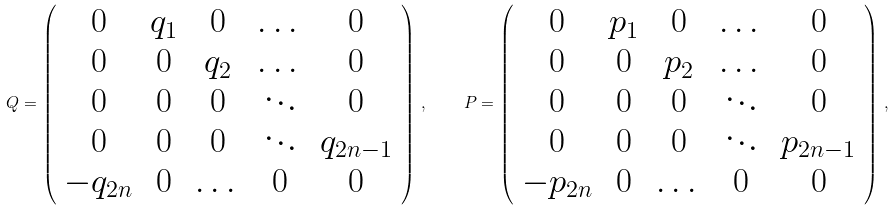Convert formula to latex. <formula><loc_0><loc_0><loc_500><loc_500>Q = \left ( \begin{array} { c c c c c } 0 & q _ { 1 } & 0 & \dots & 0 \\ 0 & 0 & q _ { 2 } & \dots & 0 \\ 0 & 0 & 0 & \ddots & 0 \\ 0 & 0 & 0 & \ddots & q _ { 2 n - 1 } \\ - q _ { 2 n } & 0 & \dots & 0 & 0 \end{array} \right ) \, , \quad P = \left ( \begin{array} { c c c c c } 0 & p _ { 1 } & 0 & \dots & 0 \\ 0 & 0 & p _ { 2 } & \dots & 0 \\ 0 & 0 & 0 & \ddots & 0 \\ 0 & 0 & 0 & \ddots & p _ { 2 n - 1 } \\ - p _ { 2 n } & 0 & \dots & 0 & 0 \end{array} \right ) \, ,</formula> 